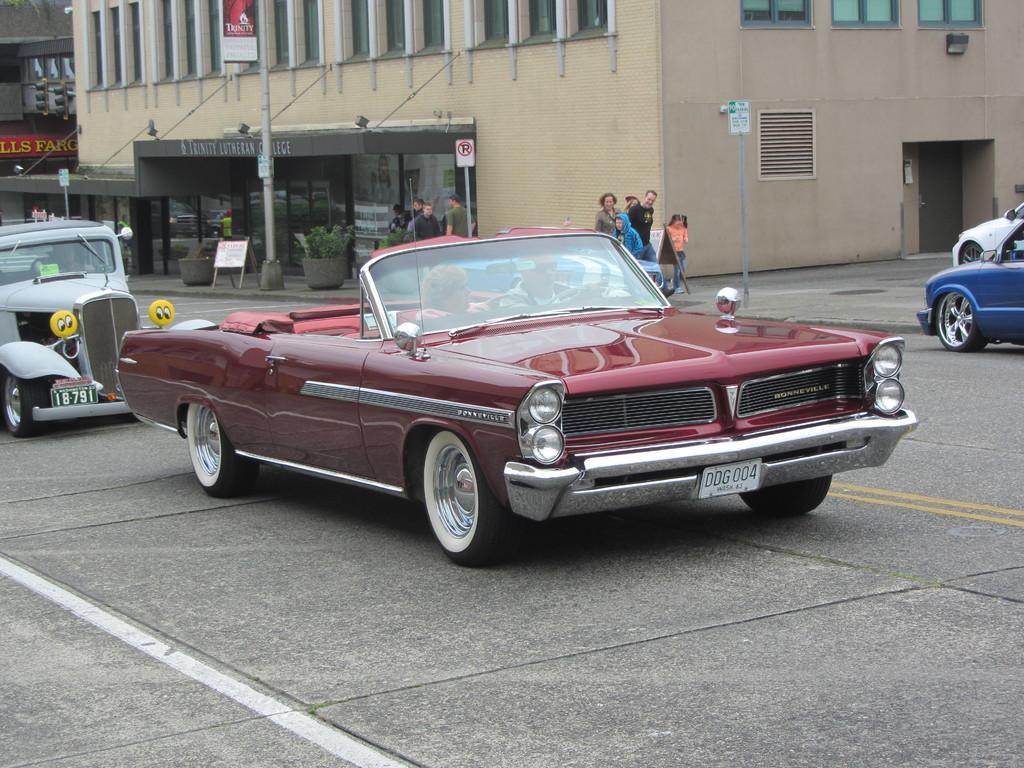How would you summarize this image in a sentence or two? In the picture I can see a maroon color car in which a person is sitting which is moving on the road. In the background, I can see a few more cars, I can see people walking on the sidewalk, I can see boards, flower pots and buildings. 